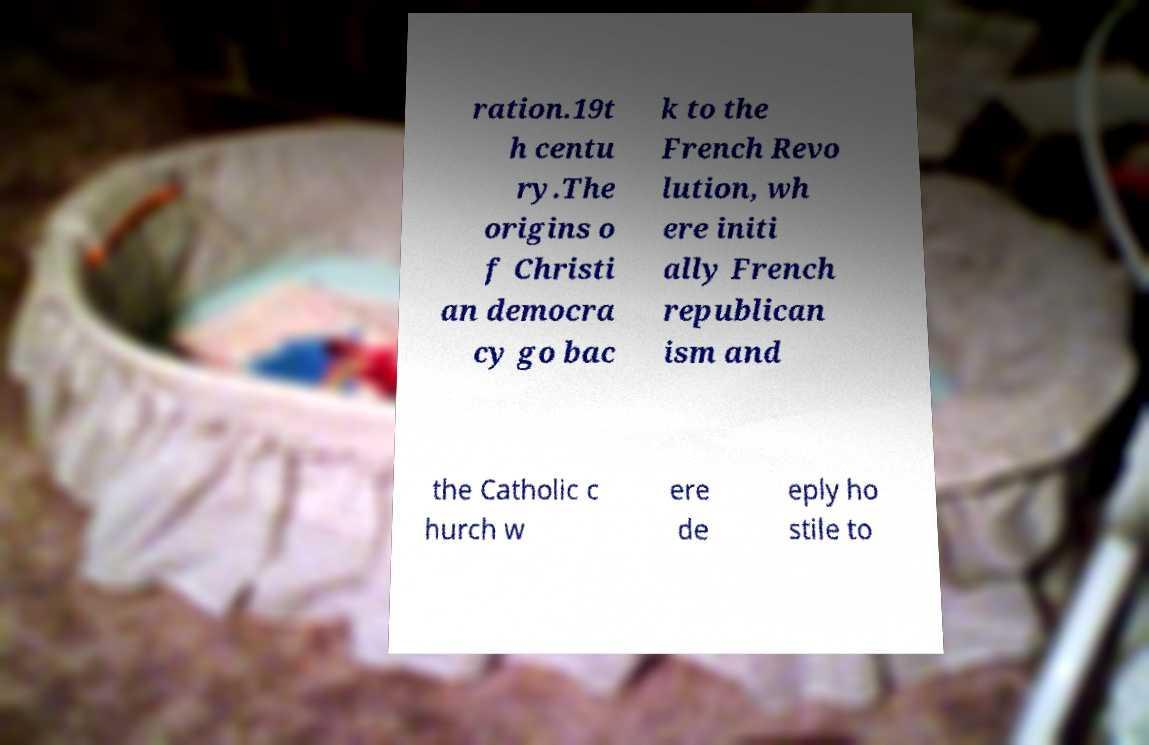Can you read and provide the text displayed in the image?This photo seems to have some interesting text. Can you extract and type it out for me? ration.19t h centu ry.The origins o f Christi an democra cy go bac k to the French Revo lution, wh ere initi ally French republican ism and the Catholic c hurch w ere de eply ho stile to 